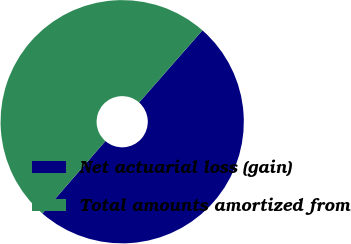Convert chart to OTSL. <chart><loc_0><loc_0><loc_500><loc_500><pie_chart><fcel>Net actuarial loss (gain)<fcel>Total amounts amortized from<nl><fcel>49.93%<fcel>50.07%<nl></chart> 